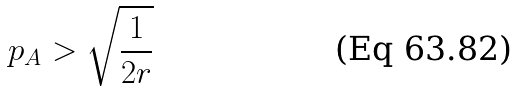Convert formula to latex. <formula><loc_0><loc_0><loc_500><loc_500>p _ { A } > \sqrt { \frac { 1 } { 2 r } }</formula> 